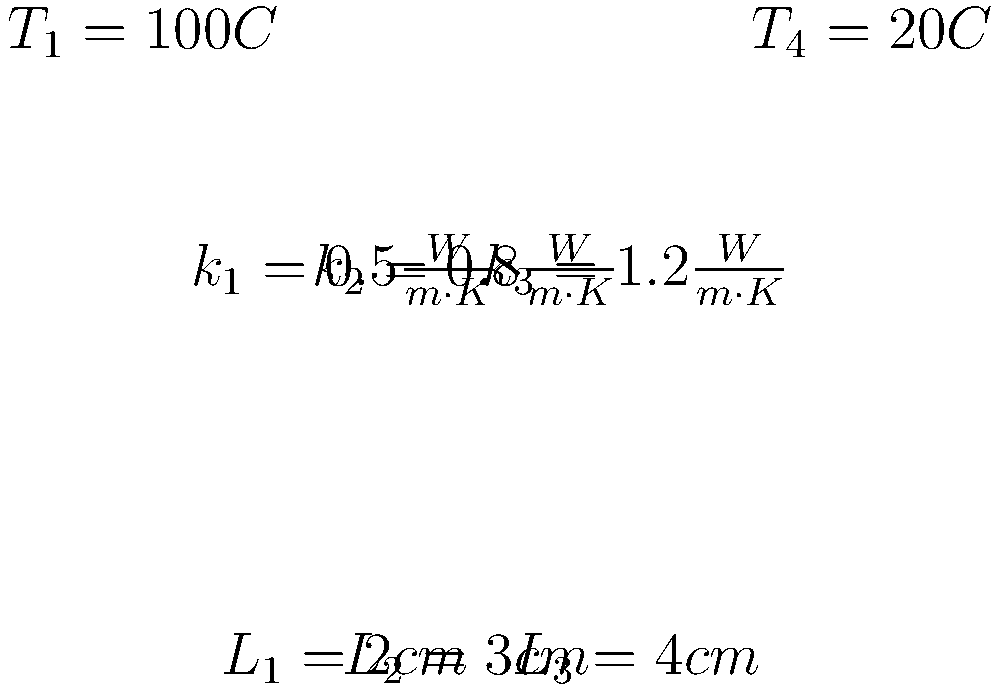A composite wall consists of three layers with different materials and thicknesses as shown in the figure. The inner surface temperature is $100°C$, and the outer surface temperature is $20°C$. Calculate the heat transfer rate per unit area through the wall. To solve this problem, we'll use the concept of thermal resistance in series for a composite wall. Here's the step-by-step solution:

1) The heat transfer rate per unit area (q) is given by:
   $$ q = \frac{T_1 - T_4}{R_{total}} $$
   where $R_{total}$ is the total thermal resistance of the wall.

2) For a composite wall, the total thermal resistance is the sum of individual resistances:
   $$ R_{total} = R_1 + R_2 + R_3 $$

3) The thermal resistance for each layer is given by:
   $$ R = \frac{L}{k} $$
   where L is the thickness and k is the thermal conductivity.

4) Calculate the resistance for each layer:
   $$ R_1 = \frac{0.02 \text{ m}}{0.5 \frac{W}{m\cdot K}} = 0.04 \frac{m^2\cdot K}{W} $$
   $$ R_2 = \frac{0.03 \text{ m}}{0.8 \frac{W}{m\cdot K}} = 0.0375 \frac{m^2\cdot K}{W} $$
   $$ R_3 = \frac{0.04 \text{ m}}{1.2 \frac{W}{m\cdot K}} = 0.0333 \frac{m^2\cdot K}{W} $$

5) Calculate the total resistance:
   $$ R_{total} = 0.04 + 0.0375 + 0.0333 = 0.1108 \frac{m^2\cdot K}{W} $$

6) Now, we can calculate the heat transfer rate per unit area:
   $$ q = \frac{100°C - 20°C}{0.1108 \frac{m^2\cdot K}{W}} = 722.02 \frac{W}{m^2} $$

Therefore, the heat transfer rate per unit area through the wall is approximately 722.02 W/m².
Answer: 722.02 W/m² 